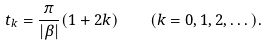<formula> <loc_0><loc_0><loc_500><loc_500>t _ { k } = \frac { \pi } { | \beta | } ( 1 + 2 k ) \quad ( k = 0 , 1 , 2 , \dots ) .</formula> 